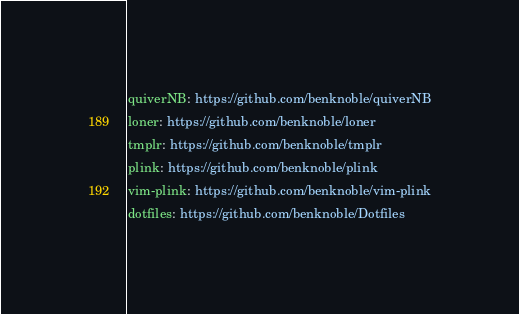<code> <loc_0><loc_0><loc_500><loc_500><_YAML_>quiverNB: https://github.com/benknoble/quiverNB
loner: https://github.com/benknoble/loner
tmplr: https://github.com/benknoble/tmplr
plink: https://github.com/benknoble/plink
vim-plink: https://github.com/benknoble/vim-plink
dotfiles: https://github.com/benknoble/Dotfiles
</code> 